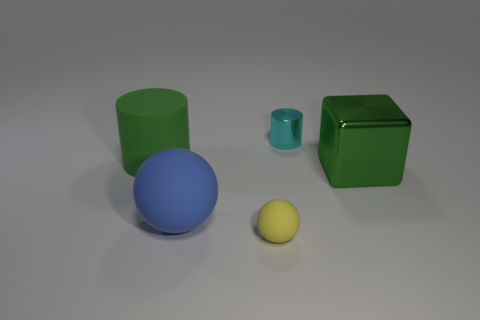Is there any pattern or symmetry in how the objects are arranged? The objects are arranged without a clear pattern or symmetry. They are placed at varying distances from each other, with different sizes and colors, which adds a random or haphazard quality to the arrangement. 